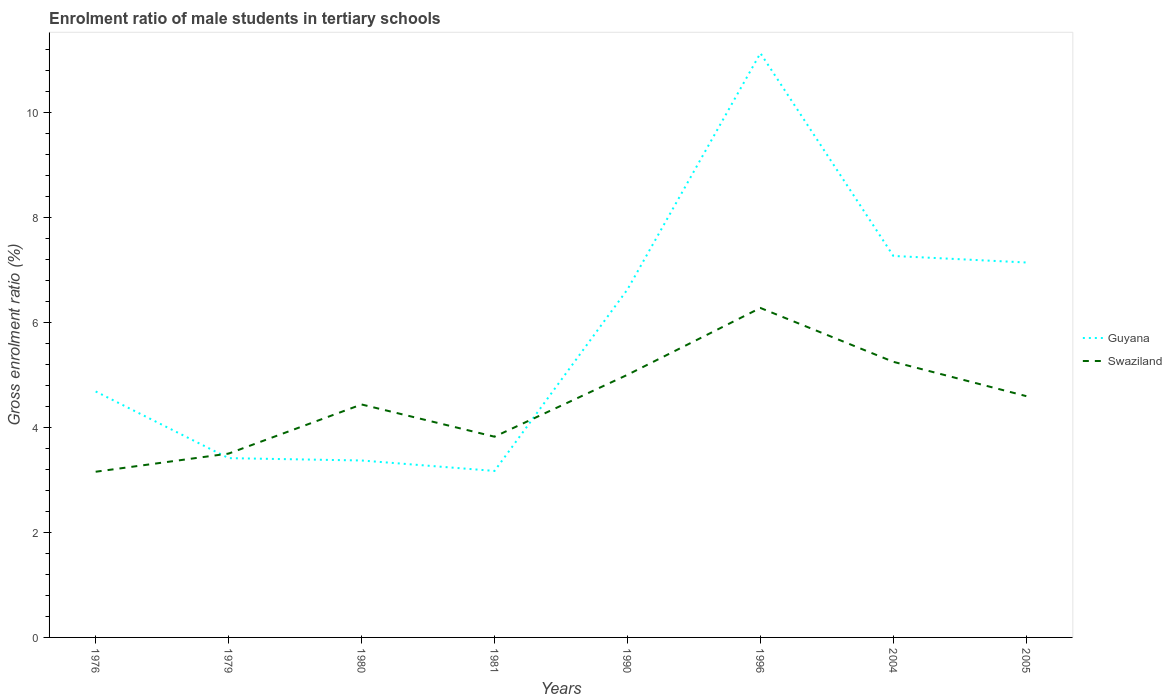How many different coloured lines are there?
Your answer should be very brief. 2. Is the number of lines equal to the number of legend labels?
Offer a very short reply. Yes. Across all years, what is the maximum enrolment ratio of male students in tertiary schools in Guyana?
Offer a very short reply. 3.17. What is the total enrolment ratio of male students in tertiary schools in Guyana in the graph?
Provide a succinct answer. -3.73. What is the difference between the highest and the second highest enrolment ratio of male students in tertiary schools in Swaziland?
Your answer should be very brief. 3.12. What is the difference between the highest and the lowest enrolment ratio of male students in tertiary schools in Swaziland?
Keep it short and to the point. 4. How many lines are there?
Your answer should be compact. 2. What is the difference between two consecutive major ticks on the Y-axis?
Your answer should be compact. 2. Does the graph contain grids?
Give a very brief answer. No. Where does the legend appear in the graph?
Keep it short and to the point. Center right. How many legend labels are there?
Your response must be concise. 2. How are the legend labels stacked?
Provide a short and direct response. Vertical. What is the title of the graph?
Offer a terse response. Enrolment ratio of male students in tertiary schools. What is the label or title of the X-axis?
Give a very brief answer. Years. What is the Gross enrolment ratio (%) of Guyana in 1976?
Offer a very short reply. 4.68. What is the Gross enrolment ratio (%) in Swaziland in 1976?
Your answer should be very brief. 3.15. What is the Gross enrolment ratio (%) in Guyana in 1979?
Your response must be concise. 3.41. What is the Gross enrolment ratio (%) of Swaziland in 1979?
Provide a short and direct response. 3.5. What is the Gross enrolment ratio (%) in Guyana in 1980?
Make the answer very short. 3.37. What is the Gross enrolment ratio (%) of Swaziland in 1980?
Offer a very short reply. 4.44. What is the Gross enrolment ratio (%) of Guyana in 1981?
Provide a short and direct response. 3.17. What is the Gross enrolment ratio (%) of Swaziland in 1981?
Make the answer very short. 3.82. What is the Gross enrolment ratio (%) in Guyana in 1990?
Give a very brief answer. 6.63. What is the Gross enrolment ratio (%) of Swaziland in 1990?
Your answer should be very brief. 5. What is the Gross enrolment ratio (%) in Guyana in 1996?
Your answer should be very brief. 11.12. What is the Gross enrolment ratio (%) of Swaziland in 1996?
Your answer should be compact. 6.27. What is the Gross enrolment ratio (%) in Guyana in 2004?
Keep it short and to the point. 7.26. What is the Gross enrolment ratio (%) in Swaziland in 2004?
Your response must be concise. 5.25. What is the Gross enrolment ratio (%) in Guyana in 2005?
Your response must be concise. 7.14. What is the Gross enrolment ratio (%) in Swaziland in 2005?
Your answer should be very brief. 4.59. Across all years, what is the maximum Gross enrolment ratio (%) of Guyana?
Provide a succinct answer. 11.12. Across all years, what is the maximum Gross enrolment ratio (%) in Swaziland?
Give a very brief answer. 6.27. Across all years, what is the minimum Gross enrolment ratio (%) in Guyana?
Keep it short and to the point. 3.17. Across all years, what is the minimum Gross enrolment ratio (%) in Swaziland?
Your response must be concise. 3.15. What is the total Gross enrolment ratio (%) of Guyana in the graph?
Your response must be concise. 46.79. What is the total Gross enrolment ratio (%) of Swaziland in the graph?
Your response must be concise. 36.03. What is the difference between the Gross enrolment ratio (%) of Guyana in 1976 and that in 1979?
Keep it short and to the point. 1.27. What is the difference between the Gross enrolment ratio (%) in Swaziland in 1976 and that in 1979?
Your response must be concise. -0.35. What is the difference between the Gross enrolment ratio (%) in Guyana in 1976 and that in 1980?
Your answer should be compact. 1.31. What is the difference between the Gross enrolment ratio (%) in Swaziland in 1976 and that in 1980?
Provide a short and direct response. -1.28. What is the difference between the Gross enrolment ratio (%) of Guyana in 1976 and that in 1981?
Offer a terse response. 1.51. What is the difference between the Gross enrolment ratio (%) of Swaziland in 1976 and that in 1981?
Offer a terse response. -0.67. What is the difference between the Gross enrolment ratio (%) of Guyana in 1976 and that in 1990?
Offer a terse response. -1.94. What is the difference between the Gross enrolment ratio (%) of Swaziland in 1976 and that in 1990?
Provide a succinct answer. -1.85. What is the difference between the Gross enrolment ratio (%) in Guyana in 1976 and that in 1996?
Your answer should be compact. -6.44. What is the difference between the Gross enrolment ratio (%) in Swaziland in 1976 and that in 1996?
Ensure brevity in your answer.  -3.12. What is the difference between the Gross enrolment ratio (%) in Guyana in 1976 and that in 2004?
Your answer should be very brief. -2.58. What is the difference between the Gross enrolment ratio (%) in Swaziland in 1976 and that in 2004?
Provide a short and direct response. -2.09. What is the difference between the Gross enrolment ratio (%) of Guyana in 1976 and that in 2005?
Offer a terse response. -2.46. What is the difference between the Gross enrolment ratio (%) of Swaziland in 1976 and that in 2005?
Your answer should be very brief. -1.44. What is the difference between the Gross enrolment ratio (%) in Guyana in 1979 and that in 1980?
Provide a succinct answer. 0.04. What is the difference between the Gross enrolment ratio (%) in Swaziland in 1979 and that in 1980?
Your response must be concise. -0.94. What is the difference between the Gross enrolment ratio (%) of Guyana in 1979 and that in 1981?
Provide a short and direct response. 0.24. What is the difference between the Gross enrolment ratio (%) of Swaziland in 1979 and that in 1981?
Your answer should be very brief. -0.32. What is the difference between the Gross enrolment ratio (%) in Guyana in 1979 and that in 1990?
Keep it short and to the point. -3.21. What is the difference between the Gross enrolment ratio (%) of Swaziland in 1979 and that in 1990?
Ensure brevity in your answer.  -1.5. What is the difference between the Gross enrolment ratio (%) of Guyana in 1979 and that in 1996?
Make the answer very short. -7.71. What is the difference between the Gross enrolment ratio (%) of Swaziland in 1979 and that in 1996?
Offer a very short reply. -2.77. What is the difference between the Gross enrolment ratio (%) in Guyana in 1979 and that in 2004?
Provide a succinct answer. -3.85. What is the difference between the Gross enrolment ratio (%) of Swaziland in 1979 and that in 2004?
Your answer should be compact. -1.75. What is the difference between the Gross enrolment ratio (%) of Guyana in 1979 and that in 2005?
Offer a very short reply. -3.73. What is the difference between the Gross enrolment ratio (%) of Swaziland in 1979 and that in 2005?
Offer a terse response. -1.09. What is the difference between the Gross enrolment ratio (%) of Guyana in 1980 and that in 1981?
Make the answer very short. 0.2. What is the difference between the Gross enrolment ratio (%) of Swaziland in 1980 and that in 1981?
Your answer should be very brief. 0.61. What is the difference between the Gross enrolment ratio (%) of Guyana in 1980 and that in 1990?
Offer a terse response. -3.26. What is the difference between the Gross enrolment ratio (%) of Swaziland in 1980 and that in 1990?
Offer a terse response. -0.56. What is the difference between the Gross enrolment ratio (%) of Guyana in 1980 and that in 1996?
Provide a short and direct response. -7.75. What is the difference between the Gross enrolment ratio (%) in Swaziland in 1980 and that in 1996?
Your response must be concise. -1.84. What is the difference between the Gross enrolment ratio (%) of Guyana in 1980 and that in 2004?
Provide a succinct answer. -3.89. What is the difference between the Gross enrolment ratio (%) of Swaziland in 1980 and that in 2004?
Provide a succinct answer. -0.81. What is the difference between the Gross enrolment ratio (%) in Guyana in 1980 and that in 2005?
Ensure brevity in your answer.  -3.77. What is the difference between the Gross enrolment ratio (%) of Swaziland in 1980 and that in 2005?
Your answer should be very brief. -0.16. What is the difference between the Gross enrolment ratio (%) of Guyana in 1981 and that in 1990?
Make the answer very short. -3.46. What is the difference between the Gross enrolment ratio (%) in Swaziland in 1981 and that in 1990?
Make the answer very short. -1.18. What is the difference between the Gross enrolment ratio (%) of Guyana in 1981 and that in 1996?
Your answer should be compact. -7.95. What is the difference between the Gross enrolment ratio (%) in Swaziland in 1981 and that in 1996?
Keep it short and to the point. -2.45. What is the difference between the Gross enrolment ratio (%) of Guyana in 1981 and that in 2004?
Provide a succinct answer. -4.09. What is the difference between the Gross enrolment ratio (%) in Swaziland in 1981 and that in 2004?
Offer a terse response. -1.43. What is the difference between the Gross enrolment ratio (%) of Guyana in 1981 and that in 2005?
Offer a terse response. -3.97. What is the difference between the Gross enrolment ratio (%) in Swaziland in 1981 and that in 2005?
Keep it short and to the point. -0.77. What is the difference between the Gross enrolment ratio (%) in Guyana in 1990 and that in 1996?
Offer a very short reply. -4.5. What is the difference between the Gross enrolment ratio (%) in Swaziland in 1990 and that in 1996?
Your answer should be very brief. -1.27. What is the difference between the Gross enrolment ratio (%) in Guyana in 1990 and that in 2004?
Provide a succinct answer. -0.64. What is the difference between the Gross enrolment ratio (%) of Swaziland in 1990 and that in 2004?
Your answer should be compact. -0.25. What is the difference between the Gross enrolment ratio (%) of Guyana in 1990 and that in 2005?
Your response must be concise. -0.51. What is the difference between the Gross enrolment ratio (%) in Swaziland in 1990 and that in 2005?
Keep it short and to the point. 0.41. What is the difference between the Gross enrolment ratio (%) of Guyana in 1996 and that in 2004?
Give a very brief answer. 3.86. What is the difference between the Gross enrolment ratio (%) in Swaziland in 1996 and that in 2004?
Your answer should be very brief. 1.03. What is the difference between the Gross enrolment ratio (%) in Guyana in 1996 and that in 2005?
Your response must be concise. 3.99. What is the difference between the Gross enrolment ratio (%) of Swaziland in 1996 and that in 2005?
Provide a short and direct response. 1.68. What is the difference between the Gross enrolment ratio (%) in Guyana in 2004 and that in 2005?
Give a very brief answer. 0.12. What is the difference between the Gross enrolment ratio (%) in Swaziland in 2004 and that in 2005?
Your answer should be compact. 0.65. What is the difference between the Gross enrolment ratio (%) in Guyana in 1976 and the Gross enrolment ratio (%) in Swaziland in 1979?
Keep it short and to the point. 1.18. What is the difference between the Gross enrolment ratio (%) of Guyana in 1976 and the Gross enrolment ratio (%) of Swaziland in 1980?
Offer a very short reply. 0.25. What is the difference between the Gross enrolment ratio (%) of Guyana in 1976 and the Gross enrolment ratio (%) of Swaziland in 1981?
Give a very brief answer. 0.86. What is the difference between the Gross enrolment ratio (%) in Guyana in 1976 and the Gross enrolment ratio (%) in Swaziland in 1990?
Offer a very short reply. -0.32. What is the difference between the Gross enrolment ratio (%) in Guyana in 1976 and the Gross enrolment ratio (%) in Swaziland in 1996?
Make the answer very short. -1.59. What is the difference between the Gross enrolment ratio (%) of Guyana in 1976 and the Gross enrolment ratio (%) of Swaziland in 2004?
Give a very brief answer. -0.56. What is the difference between the Gross enrolment ratio (%) in Guyana in 1976 and the Gross enrolment ratio (%) in Swaziland in 2005?
Keep it short and to the point. 0.09. What is the difference between the Gross enrolment ratio (%) in Guyana in 1979 and the Gross enrolment ratio (%) in Swaziland in 1980?
Your answer should be very brief. -1.02. What is the difference between the Gross enrolment ratio (%) in Guyana in 1979 and the Gross enrolment ratio (%) in Swaziland in 1981?
Provide a short and direct response. -0.41. What is the difference between the Gross enrolment ratio (%) of Guyana in 1979 and the Gross enrolment ratio (%) of Swaziland in 1990?
Provide a succinct answer. -1.59. What is the difference between the Gross enrolment ratio (%) of Guyana in 1979 and the Gross enrolment ratio (%) of Swaziland in 1996?
Give a very brief answer. -2.86. What is the difference between the Gross enrolment ratio (%) in Guyana in 1979 and the Gross enrolment ratio (%) in Swaziland in 2004?
Make the answer very short. -1.83. What is the difference between the Gross enrolment ratio (%) of Guyana in 1979 and the Gross enrolment ratio (%) of Swaziland in 2005?
Give a very brief answer. -1.18. What is the difference between the Gross enrolment ratio (%) in Guyana in 1980 and the Gross enrolment ratio (%) in Swaziland in 1981?
Your answer should be very brief. -0.45. What is the difference between the Gross enrolment ratio (%) in Guyana in 1980 and the Gross enrolment ratio (%) in Swaziland in 1990?
Provide a short and direct response. -1.63. What is the difference between the Gross enrolment ratio (%) of Guyana in 1980 and the Gross enrolment ratio (%) of Swaziland in 1996?
Ensure brevity in your answer.  -2.9. What is the difference between the Gross enrolment ratio (%) in Guyana in 1980 and the Gross enrolment ratio (%) in Swaziland in 2004?
Offer a very short reply. -1.88. What is the difference between the Gross enrolment ratio (%) of Guyana in 1980 and the Gross enrolment ratio (%) of Swaziland in 2005?
Provide a short and direct response. -1.23. What is the difference between the Gross enrolment ratio (%) in Guyana in 1981 and the Gross enrolment ratio (%) in Swaziland in 1990?
Give a very brief answer. -1.83. What is the difference between the Gross enrolment ratio (%) in Guyana in 1981 and the Gross enrolment ratio (%) in Swaziland in 1996?
Offer a terse response. -3.1. What is the difference between the Gross enrolment ratio (%) of Guyana in 1981 and the Gross enrolment ratio (%) of Swaziland in 2004?
Offer a very short reply. -2.08. What is the difference between the Gross enrolment ratio (%) of Guyana in 1981 and the Gross enrolment ratio (%) of Swaziland in 2005?
Ensure brevity in your answer.  -1.42. What is the difference between the Gross enrolment ratio (%) in Guyana in 1990 and the Gross enrolment ratio (%) in Swaziland in 1996?
Ensure brevity in your answer.  0.35. What is the difference between the Gross enrolment ratio (%) of Guyana in 1990 and the Gross enrolment ratio (%) of Swaziland in 2004?
Your response must be concise. 1.38. What is the difference between the Gross enrolment ratio (%) in Guyana in 1990 and the Gross enrolment ratio (%) in Swaziland in 2005?
Provide a succinct answer. 2.03. What is the difference between the Gross enrolment ratio (%) in Guyana in 1996 and the Gross enrolment ratio (%) in Swaziland in 2004?
Your answer should be very brief. 5.88. What is the difference between the Gross enrolment ratio (%) of Guyana in 1996 and the Gross enrolment ratio (%) of Swaziland in 2005?
Your response must be concise. 6.53. What is the difference between the Gross enrolment ratio (%) in Guyana in 2004 and the Gross enrolment ratio (%) in Swaziland in 2005?
Provide a short and direct response. 2.67. What is the average Gross enrolment ratio (%) of Guyana per year?
Ensure brevity in your answer.  5.85. What is the average Gross enrolment ratio (%) of Swaziland per year?
Make the answer very short. 4.5. In the year 1976, what is the difference between the Gross enrolment ratio (%) of Guyana and Gross enrolment ratio (%) of Swaziland?
Make the answer very short. 1.53. In the year 1979, what is the difference between the Gross enrolment ratio (%) of Guyana and Gross enrolment ratio (%) of Swaziland?
Your answer should be very brief. -0.09. In the year 1980, what is the difference between the Gross enrolment ratio (%) of Guyana and Gross enrolment ratio (%) of Swaziland?
Provide a succinct answer. -1.07. In the year 1981, what is the difference between the Gross enrolment ratio (%) of Guyana and Gross enrolment ratio (%) of Swaziland?
Your answer should be compact. -0.65. In the year 1990, what is the difference between the Gross enrolment ratio (%) in Guyana and Gross enrolment ratio (%) in Swaziland?
Your response must be concise. 1.62. In the year 1996, what is the difference between the Gross enrolment ratio (%) in Guyana and Gross enrolment ratio (%) in Swaziland?
Keep it short and to the point. 4.85. In the year 2004, what is the difference between the Gross enrolment ratio (%) in Guyana and Gross enrolment ratio (%) in Swaziland?
Give a very brief answer. 2.02. In the year 2005, what is the difference between the Gross enrolment ratio (%) in Guyana and Gross enrolment ratio (%) in Swaziland?
Ensure brevity in your answer.  2.54. What is the ratio of the Gross enrolment ratio (%) of Guyana in 1976 to that in 1979?
Your answer should be very brief. 1.37. What is the ratio of the Gross enrolment ratio (%) in Swaziland in 1976 to that in 1979?
Provide a succinct answer. 0.9. What is the ratio of the Gross enrolment ratio (%) of Guyana in 1976 to that in 1980?
Your response must be concise. 1.39. What is the ratio of the Gross enrolment ratio (%) of Swaziland in 1976 to that in 1980?
Ensure brevity in your answer.  0.71. What is the ratio of the Gross enrolment ratio (%) in Guyana in 1976 to that in 1981?
Offer a very short reply. 1.48. What is the ratio of the Gross enrolment ratio (%) in Swaziland in 1976 to that in 1981?
Your response must be concise. 0.83. What is the ratio of the Gross enrolment ratio (%) of Guyana in 1976 to that in 1990?
Offer a very short reply. 0.71. What is the ratio of the Gross enrolment ratio (%) of Swaziland in 1976 to that in 1990?
Provide a short and direct response. 0.63. What is the ratio of the Gross enrolment ratio (%) of Guyana in 1976 to that in 1996?
Ensure brevity in your answer.  0.42. What is the ratio of the Gross enrolment ratio (%) of Swaziland in 1976 to that in 1996?
Provide a succinct answer. 0.5. What is the ratio of the Gross enrolment ratio (%) of Guyana in 1976 to that in 2004?
Make the answer very short. 0.64. What is the ratio of the Gross enrolment ratio (%) of Swaziland in 1976 to that in 2004?
Your answer should be very brief. 0.6. What is the ratio of the Gross enrolment ratio (%) in Guyana in 1976 to that in 2005?
Make the answer very short. 0.66. What is the ratio of the Gross enrolment ratio (%) of Swaziland in 1976 to that in 2005?
Make the answer very short. 0.69. What is the ratio of the Gross enrolment ratio (%) in Guyana in 1979 to that in 1980?
Give a very brief answer. 1.01. What is the ratio of the Gross enrolment ratio (%) in Swaziland in 1979 to that in 1980?
Ensure brevity in your answer.  0.79. What is the ratio of the Gross enrolment ratio (%) in Swaziland in 1979 to that in 1981?
Ensure brevity in your answer.  0.92. What is the ratio of the Gross enrolment ratio (%) in Guyana in 1979 to that in 1990?
Provide a succinct answer. 0.52. What is the ratio of the Gross enrolment ratio (%) in Swaziland in 1979 to that in 1990?
Ensure brevity in your answer.  0.7. What is the ratio of the Gross enrolment ratio (%) in Guyana in 1979 to that in 1996?
Offer a terse response. 0.31. What is the ratio of the Gross enrolment ratio (%) of Swaziland in 1979 to that in 1996?
Your response must be concise. 0.56. What is the ratio of the Gross enrolment ratio (%) of Guyana in 1979 to that in 2004?
Your answer should be compact. 0.47. What is the ratio of the Gross enrolment ratio (%) in Swaziland in 1979 to that in 2004?
Keep it short and to the point. 0.67. What is the ratio of the Gross enrolment ratio (%) of Guyana in 1979 to that in 2005?
Give a very brief answer. 0.48. What is the ratio of the Gross enrolment ratio (%) in Swaziland in 1979 to that in 2005?
Keep it short and to the point. 0.76. What is the ratio of the Gross enrolment ratio (%) of Guyana in 1980 to that in 1981?
Offer a very short reply. 1.06. What is the ratio of the Gross enrolment ratio (%) of Swaziland in 1980 to that in 1981?
Your answer should be compact. 1.16. What is the ratio of the Gross enrolment ratio (%) of Guyana in 1980 to that in 1990?
Provide a short and direct response. 0.51. What is the ratio of the Gross enrolment ratio (%) of Swaziland in 1980 to that in 1990?
Your response must be concise. 0.89. What is the ratio of the Gross enrolment ratio (%) in Guyana in 1980 to that in 1996?
Provide a succinct answer. 0.3. What is the ratio of the Gross enrolment ratio (%) in Swaziland in 1980 to that in 1996?
Your answer should be very brief. 0.71. What is the ratio of the Gross enrolment ratio (%) in Guyana in 1980 to that in 2004?
Your response must be concise. 0.46. What is the ratio of the Gross enrolment ratio (%) of Swaziland in 1980 to that in 2004?
Make the answer very short. 0.85. What is the ratio of the Gross enrolment ratio (%) in Guyana in 1980 to that in 2005?
Your answer should be very brief. 0.47. What is the ratio of the Gross enrolment ratio (%) of Swaziland in 1980 to that in 2005?
Ensure brevity in your answer.  0.97. What is the ratio of the Gross enrolment ratio (%) of Guyana in 1981 to that in 1990?
Keep it short and to the point. 0.48. What is the ratio of the Gross enrolment ratio (%) of Swaziland in 1981 to that in 1990?
Keep it short and to the point. 0.76. What is the ratio of the Gross enrolment ratio (%) in Guyana in 1981 to that in 1996?
Your response must be concise. 0.28. What is the ratio of the Gross enrolment ratio (%) of Swaziland in 1981 to that in 1996?
Make the answer very short. 0.61. What is the ratio of the Gross enrolment ratio (%) of Guyana in 1981 to that in 2004?
Provide a succinct answer. 0.44. What is the ratio of the Gross enrolment ratio (%) in Swaziland in 1981 to that in 2004?
Provide a short and direct response. 0.73. What is the ratio of the Gross enrolment ratio (%) of Guyana in 1981 to that in 2005?
Make the answer very short. 0.44. What is the ratio of the Gross enrolment ratio (%) of Swaziland in 1981 to that in 2005?
Make the answer very short. 0.83. What is the ratio of the Gross enrolment ratio (%) of Guyana in 1990 to that in 1996?
Keep it short and to the point. 0.6. What is the ratio of the Gross enrolment ratio (%) of Swaziland in 1990 to that in 1996?
Your answer should be very brief. 0.8. What is the ratio of the Gross enrolment ratio (%) of Guyana in 1990 to that in 2004?
Your answer should be compact. 0.91. What is the ratio of the Gross enrolment ratio (%) in Swaziland in 1990 to that in 2004?
Provide a short and direct response. 0.95. What is the ratio of the Gross enrolment ratio (%) of Guyana in 1990 to that in 2005?
Your answer should be compact. 0.93. What is the ratio of the Gross enrolment ratio (%) in Swaziland in 1990 to that in 2005?
Your answer should be compact. 1.09. What is the ratio of the Gross enrolment ratio (%) in Guyana in 1996 to that in 2004?
Your answer should be very brief. 1.53. What is the ratio of the Gross enrolment ratio (%) in Swaziland in 1996 to that in 2004?
Your response must be concise. 1.2. What is the ratio of the Gross enrolment ratio (%) in Guyana in 1996 to that in 2005?
Keep it short and to the point. 1.56. What is the ratio of the Gross enrolment ratio (%) of Swaziland in 1996 to that in 2005?
Ensure brevity in your answer.  1.37. What is the ratio of the Gross enrolment ratio (%) of Guyana in 2004 to that in 2005?
Make the answer very short. 1.02. What is the ratio of the Gross enrolment ratio (%) in Swaziland in 2004 to that in 2005?
Provide a succinct answer. 1.14. What is the difference between the highest and the second highest Gross enrolment ratio (%) of Guyana?
Ensure brevity in your answer.  3.86. What is the difference between the highest and the second highest Gross enrolment ratio (%) of Swaziland?
Your answer should be very brief. 1.03. What is the difference between the highest and the lowest Gross enrolment ratio (%) in Guyana?
Provide a short and direct response. 7.95. What is the difference between the highest and the lowest Gross enrolment ratio (%) in Swaziland?
Provide a short and direct response. 3.12. 